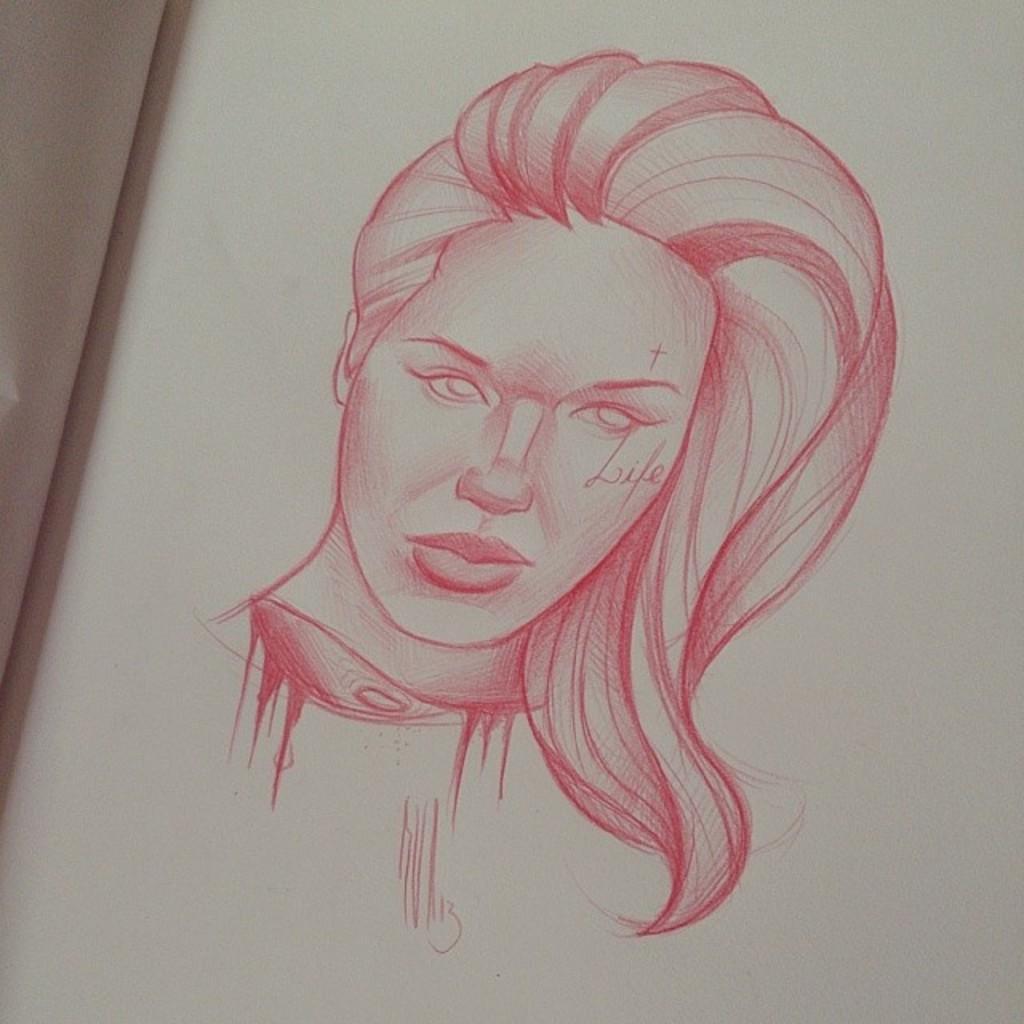Can you describe this image briefly? Here we can see drawing of a person. 